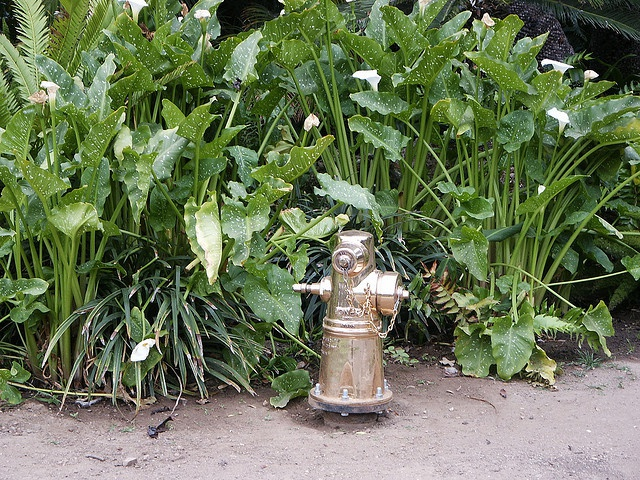Describe the objects in this image and their specific colors. I can see a fire hydrant in black, darkgray, white, tan, and gray tones in this image. 